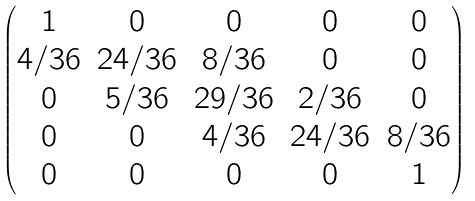<formula> <loc_0><loc_0><loc_500><loc_500>\begin{pmatrix} 1 & 0 & 0 & 0 & 0 \\ 4 / 3 6 & 2 4 / 3 6 & 8 / 3 6 & 0 & 0 \\ 0 & 5 / 3 6 & 2 9 / 3 6 & 2 / 3 6 & 0 \\ 0 & 0 & 4 / 3 6 & 2 4 / 3 6 & 8 / 3 6 \\ 0 & 0 & 0 & 0 & 1 \end{pmatrix}</formula> 